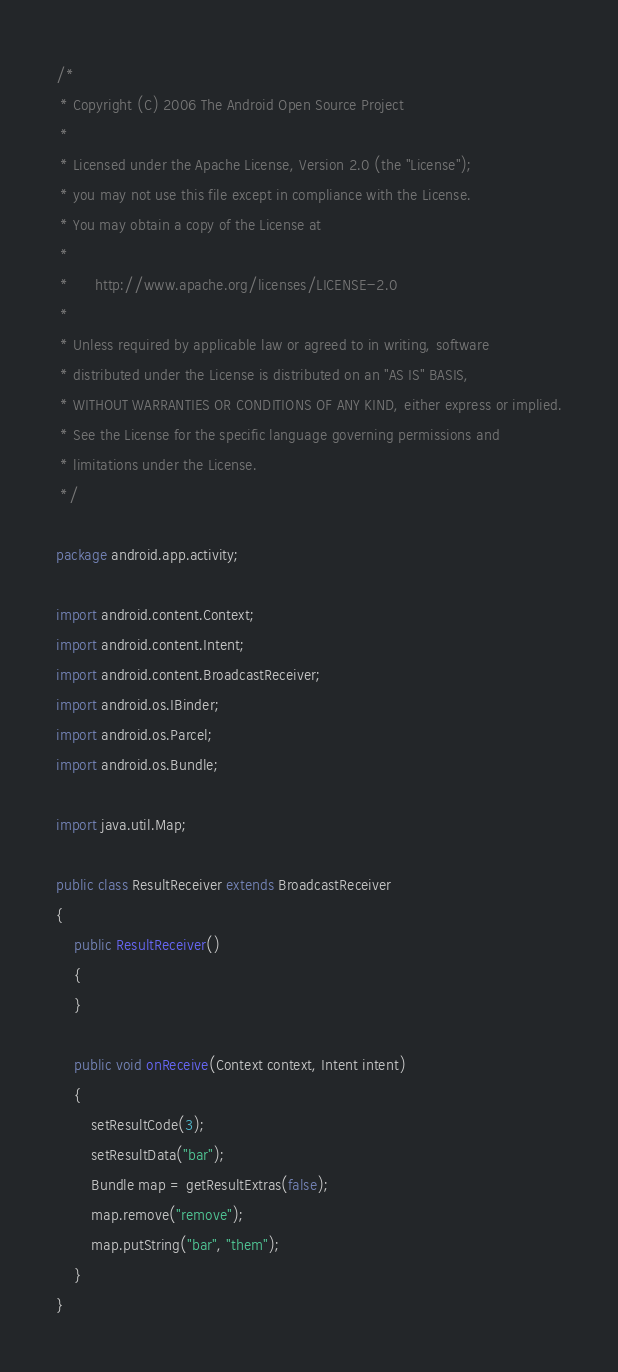<code> <loc_0><loc_0><loc_500><loc_500><_Java_>/*
 * Copyright (C) 2006 The Android Open Source Project
 *
 * Licensed under the Apache License, Version 2.0 (the "License");
 * you may not use this file except in compliance with the License.
 * You may obtain a copy of the License at
 *
 *      http://www.apache.org/licenses/LICENSE-2.0
 *
 * Unless required by applicable law or agreed to in writing, software
 * distributed under the License is distributed on an "AS IS" BASIS,
 * WITHOUT WARRANTIES OR CONDITIONS OF ANY KIND, either express or implied.
 * See the License for the specific language governing permissions and
 * limitations under the License.
 */

package android.app.activity;

import android.content.Context;
import android.content.Intent;
import android.content.BroadcastReceiver;
import android.os.IBinder;
import android.os.Parcel;
import android.os.Bundle;

import java.util.Map;

public class ResultReceiver extends BroadcastReceiver
{
    public ResultReceiver()
    {
    }

    public void onReceive(Context context, Intent intent)
    {
        setResultCode(3);
        setResultData("bar");
        Bundle map = getResultExtras(false);
        map.remove("remove");
        map.putString("bar", "them");
    }
}

</code> 